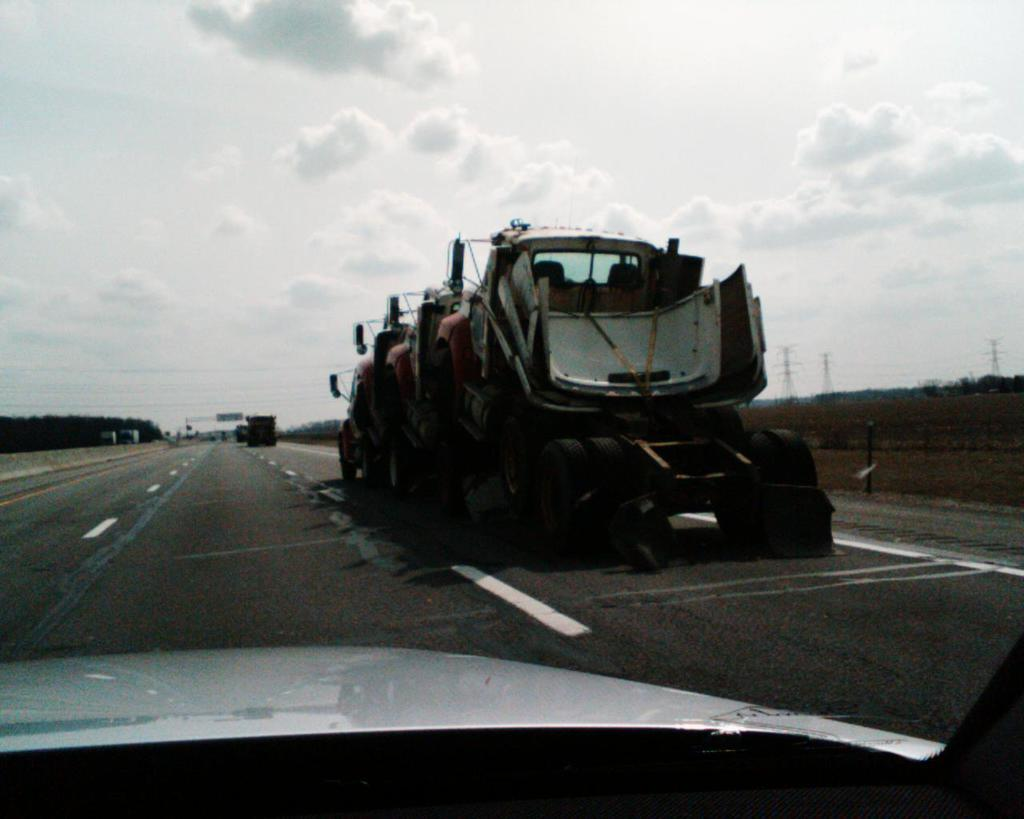How many trucks are visible in the image? There are three trucks in the image. How are the trucks positioned in relation to each other? The trucks are parked one above the other. Where are the trucks located? The trucks are on the road. What can be seen in the foreground of the image? There is a group of poles in the foreground of the image. What is the condition of the sky in the image? The sky is cloudy in the image. What type of shirt is the protest leader wearing in the image? There is no protest leader or shirt present in the image; it features three trucks parked one above the other on the road. 